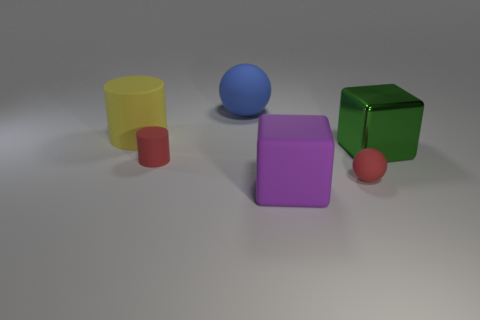Add 2 red cubes. How many objects exist? 8 Subtract all cylinders. How many objects are left? 4 Add 2 big matte objects. How many big matte objects exist? 5 Subtract 0 blue cylinders. How many objects are left? 6 Subtract all small balls. Subtract all red matte spheres. How many objects are left? 4 Add 1 big rubber objects. How many big rubber objects are left? 4 